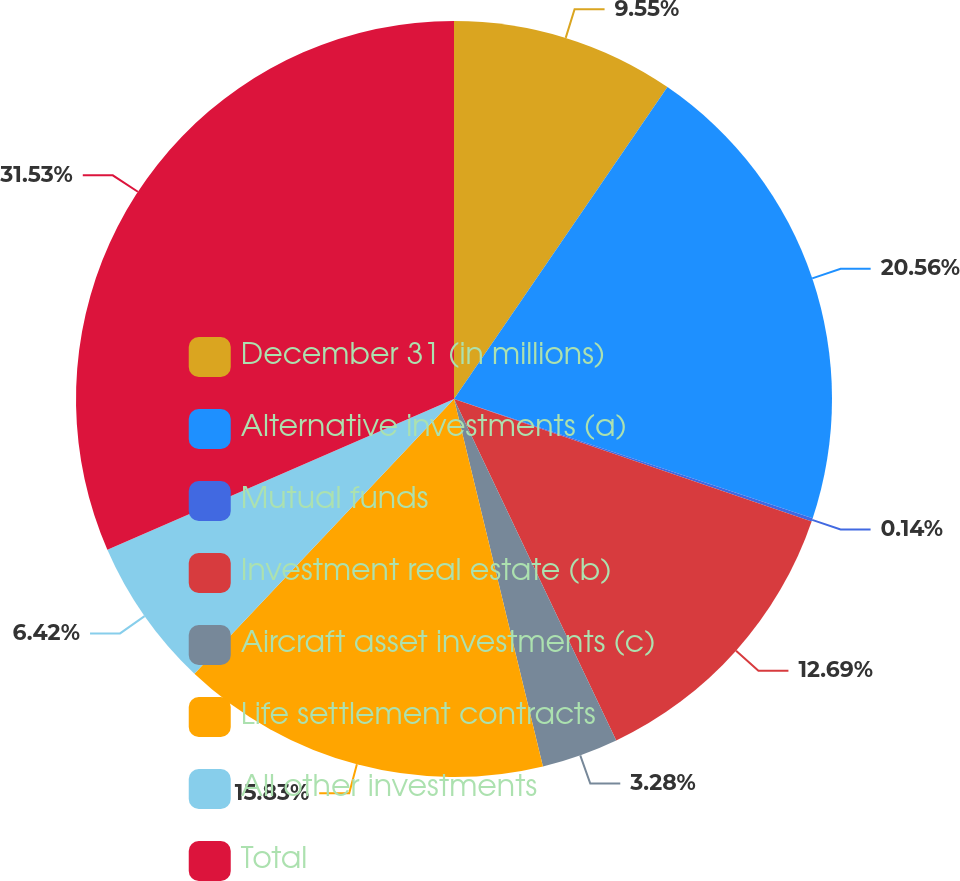Convert chart to OTSL. <chart><loc_0><loc_0><loc_500><loc_500><pie_chart><fcel>December 31 (in millions)<fcel>Alternative investments (a)<fcel>Mutual funds<fcel>Investment real estate (b)<fcel>Aircraft asset investments (c)<fcel>Life settlement contracts<fcel>All other investments<fcel>Total<nl><fcel>9.55%<fcel>20.56%<fcel>0.14%<fcel>12.69%<fcel>3.28%<fcel>15.83%<fcel>6.42%<fcel>31.53%<nl></chart> 